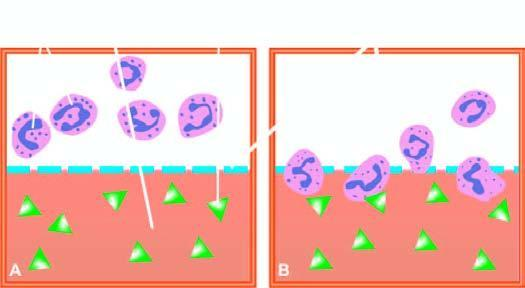does lower half of chamber show migration of neutrophils towards chemotactic agent?
Answer the question using a single word or phrase. Yes 